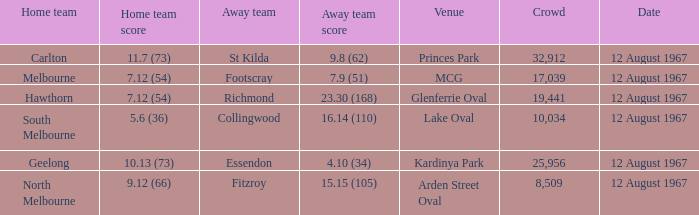What is the date of the game between Melbourne and Footscray? 12 August 1967. 